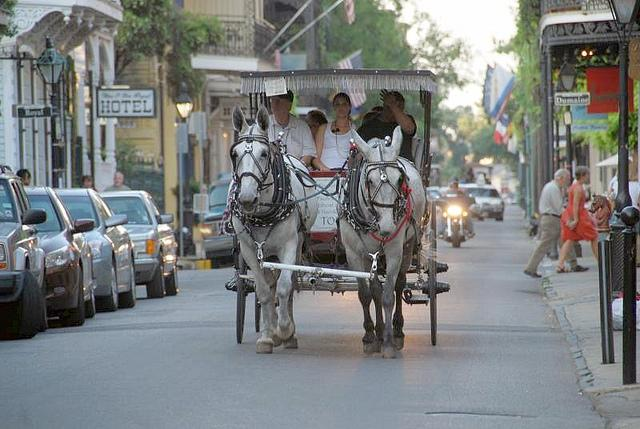Why are there horses in front of the carriage? Please explain your reasoning. to pull. They are puling the carriage. 